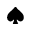Convert formula to latex. <formula><loc_0><loc_0><loc_500><loc_500>^ { a } d e s u i t</formula> 